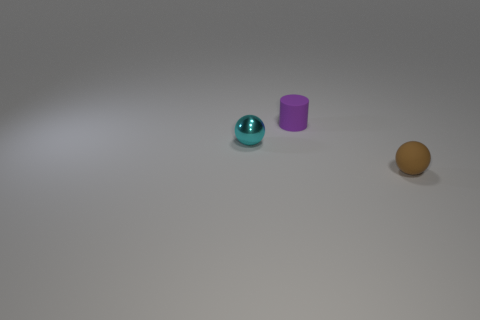Add 1 small rubber objects. How many objects exist? 4 Subtract 2 balls. How many balls are left? 0 Subtract 1 purple cylinders. How many objects are left? 2 Subtract all spheres. How many objects are left? 1 Subtract all blue cylinders. Subtract all blue spheres. How many cylinders are left? 1 Subtract all brown cylinders. How many cyan balls are left? 1 Subtract all rubber cylinders. Subtract all rubber objects. How many objects are left? 0 Add 3 tiny balls. How many tiny balls are left? 5 Add 3 tiny purple things. How many tiny purple things exist? 4 Subtract all cyan balls. How many balls are left? 1 